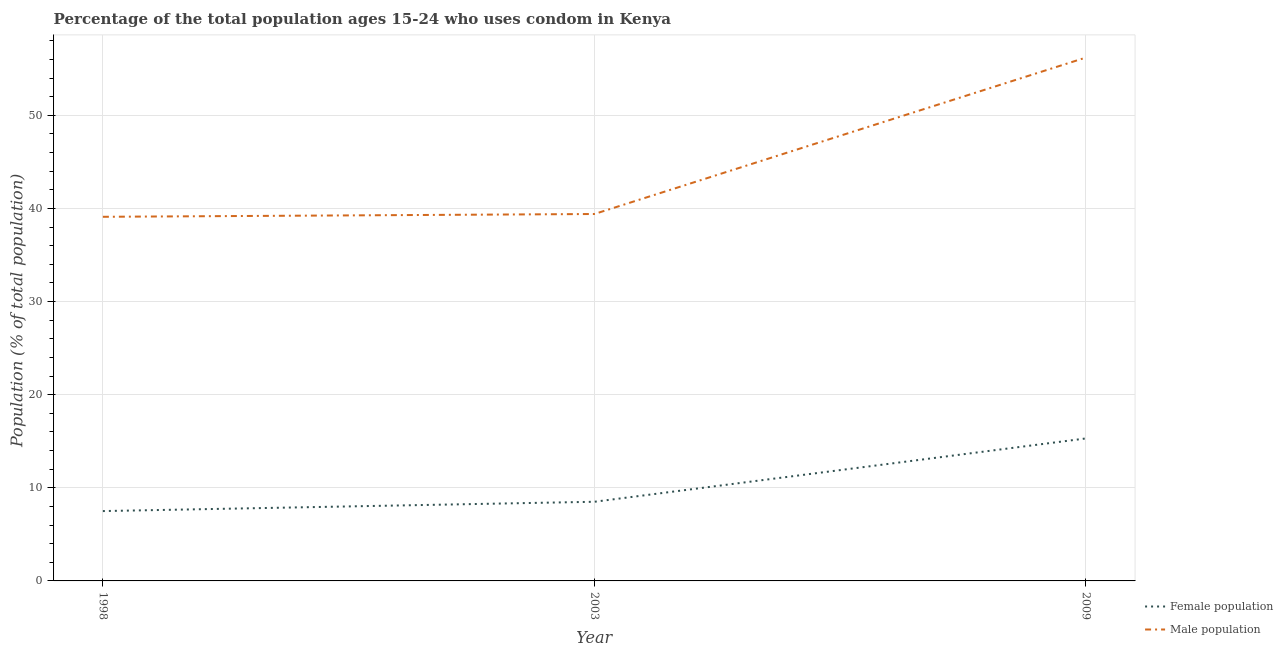What is the male population in 2009?
Your answer should be very brief. 56.2. Across all years, what is the maximum female population?
Your answer should be compact. 15.3. Across all years, what is the minimum male population?
Make the answer very short. 39.1. In which year was the female population maximum?
Ensure brevity in your answer.  2009. What is the total female population in the graph?
Give a very brief answer. 31.3. What is the difference between the male population in 1998 and that in 2009?
Your response must be concise. -17.1. What is the difference between the female population in 2003 and the male population in 1998?
Your answer should be compact. -30.6. What is the average female population per year?
Offer a terse response. 10.43. In the year 2003, what is the difference between the female population and male population?
Provide a short and direct response. -30.9. What is the ratio of the male population in 1998 to that in 2009?
Provide a succinct answer. 0.7. What is the difference between the highest and the second highest male population?
Give a very brief answer. 16.8. What is the difference between the highest and the lowest male population?
Offer a terse response. 17.1. Is the sum of the female population in 2003 and 2009 greater than the maximum male population across all years?
Make the answer very short. No. How many lines are there?
Provide a short and direct response. 2. Are the values on the major ticks of Y-axis written in scientific E-notation?
Provide a short and direct response. No. Where does the legend appear in the graph?
Your answer should be very brief. Bottom right. How are the legend labels stacked?
Make the answer very short. Vertical. What is the title of the graph?
Ensure brevity in your answer.  Percentage of the total population ages 15-24 who uses condom in Kenya. What is the label or title of the X-axis?
Keep it short and to the point. Year. What is the label or title of the Y-axis?
Keep it short and to the point. Population (% of total population) . What is the Population (% of total population)  of Male population in 1998?
Give a very brief answer. 39.1. What is the Population (% of total population)  in Female population in 2003?
Provide a short and direct response. 8.5. What is the Population (% of total population)  in Male population in 2003?
Your answer should be compact. 39.4. What is the Population (% of total population)  in Male population in 2009?
Your answer should be very brief. 56.2. Across all years, what is the maximum Population (% of total population)  of Male population?
Offer a very short reply. 56.2. Across all years, what is the minimum Population (% of total population)  of Female population?
Your answer should be very brief. 7.5. Across all years, what is the minimum Population (% of total population)  in Male population?
Give a very brief answer. 39.1. What is the total Population (% of total population)  in Female population in the graph?
Provide a succinct answer. 31.3. What is the total Population (% of total population)  of Male population in the graph?
Your answer should be very brief. 134.7. What is the difference between the Population (% of total population)  in Male population in 1998 and that in 2003?
Offer a terse response. -0.3. What is the difference between the Population (% of total population)  in Male population in 1998 and that in 2009?
Keep it short and to the point. -17.1. What is the difference between the Population (% of total population)  of Male population in 2003 and that in 2009?
Your response must be concise. -16.8. What is the difference between the Population (% of total population)  of Female population in 1998 and the Population (% of total population)  of Male population in 2003?
Provide a short and direct response. -31.9. What is the difference between the Population (% of total population)  of Female population in 1998 and the Population (% of total population)  of Male population in 2009?
Keep it short and to the point. -48.7. What is the difference between the Population (% of total population)  in Female population in 2003 and the Population (% of total population)  in Male population in 2009?
Your answer should be compact. -47.7. What is the average Population (% of total population)  in Female population per year?
Provide a short and direct response. 10.43. What is the average Population (% of total population)  in Male population per year?
Make the answer very short. 44.9. In the year 1998, what is the difference between the Population (% of total population)  in Female population and Population (% of total population)  in Male population?
Keep it short and to the point. -31.6. In the year 2003, what is the difference between the Population (% of total population)  in Female population and Population (% of total population)  in Male population?
Provide a succinct answer. -30.9. In the year 2009, what is the difference between the Population (% of total population)  of Female population and Population (% of total population)  of Male population?
Keep it short and to the point. -40.9. What is the ratio of the Population (% of total population)  in Female population in 1998 to that in 2003?
Offer a very short reply. 0.88. What is the ratio of the Population (% of total population)  in Male population in 1998 to that in 2003?
Provide a succinct answer. 0.99. What is the ratio of the Population (% of total population)  of Female population in 1998 to that in 2009?
Keep it short and to the point. 0.49. What is the ratio of the Population (% of total population)  of Male population in 1998 to that in 2009?
Make the answer very short. 0.7. What is the ratio of the Population (% of total population)  in Female population in 2003 to that in 2009?
Keep it short and to the point. 0.56. What is the ratio of the Population (% of total population)  of Male population in 2003 to that in 2009?
Offer a terse response. 0.7. What is the difference between the highest and the second highest Population (% of total population)  in Male population?
Make the answer very short. 16.8. What is the difference between the highest and the lowest Population (% of total population)  of Female population?
Keep it short and to the point. 7.8. 